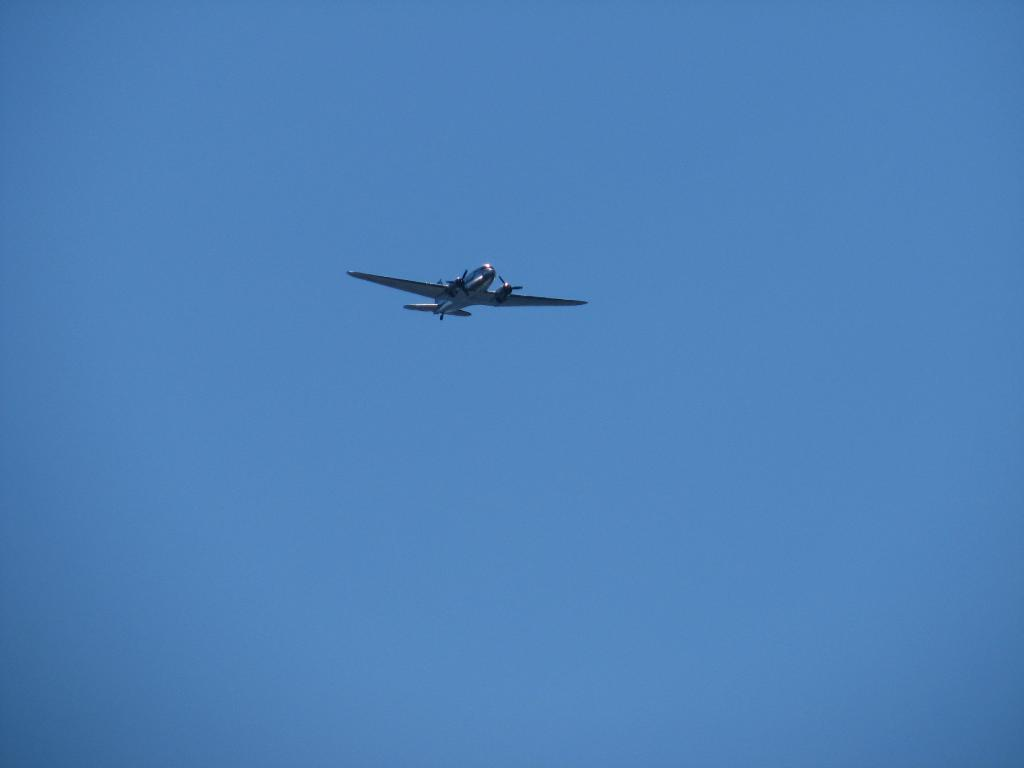What is the main subject of the image? The main subject of the image is an airplane. Can you describe the location of the airplane in the image? The airplane is in the air in the image. What can be seen in the background of the image? The sky is visible in the background of the image. What type of milk is being served on the bridge in the image? There is no milk or bridge present in the image; it features an airplane in the air. 